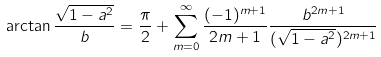Convert formula to latex. <formula><loc_0><loc_0><loc_500><loc_500>\arctan \frac { \sqrt { 1 - a ^ { 2 } } } { b } = \frac { \pi } { 2 } + \sum _ { m = 0 } ^ { \infty } \frac { ( - 1 ) ^ { m + 1 } } { 2 m + 1 } \frac { b ^ { 2 m + 1 } } { ( \sqrt { 1 - a ^ { 2 } } ) ^ { 2 m + 1 } }</formula> 